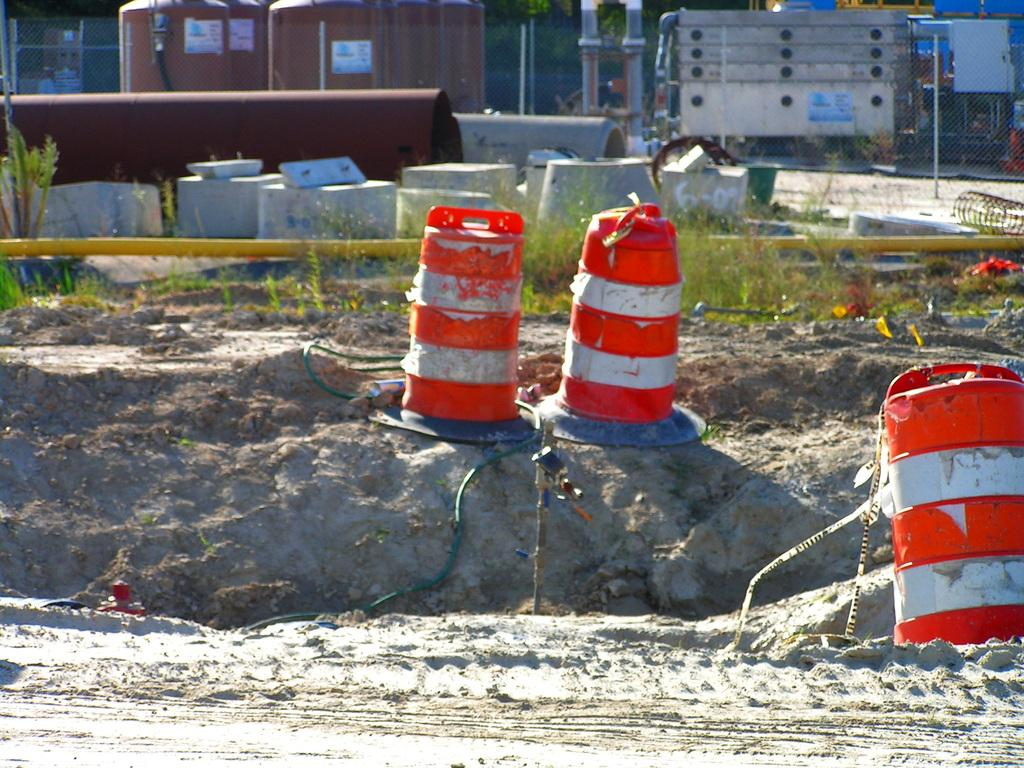What type of equipment can be seen in the image? There are pipes and tanks in the image. What is supporting the equipment in the image? There is a stand in the image that supports the equipment. What colors are the objects in the image? The objects in the image are orange and white. What type of surface can be seen in the image? The objects are placed on a sand surface. What type of glue is being used to hold the objects together in the image? There is no glue visible in the image, and the objects are not shown to be held together. 